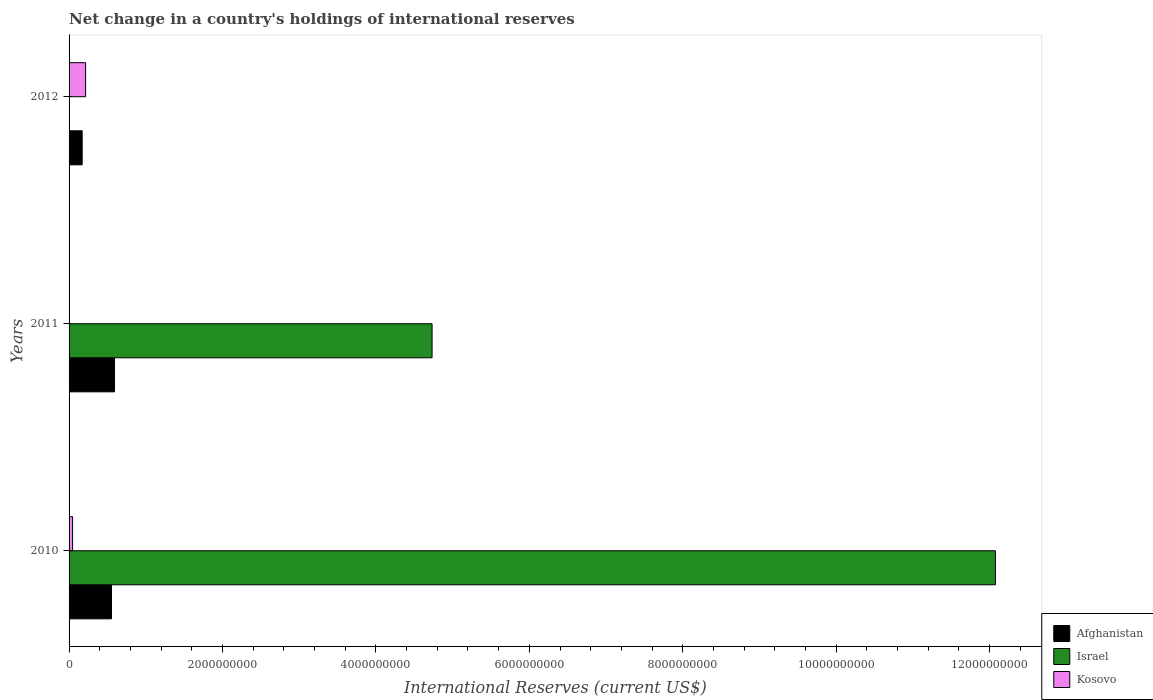Are the number of bars per tick equal to the number of legend labels?
Offer a terse response. No. Are the number of bars on each tick of the Y-axis equal?
Keep it short and to the point. No. What is the label of the 2nd group of bars from the top?
Give a very brief answer. 2011. In how many cases, is the number of bars for a given year not equal to the number of legend labels?
Provide a short and direct response. 2. Across all years, what is the maximum international reserves in Kosovo?
Provide a succinct answer. 2.16e+08. Across all years, what is the minimum international reserves in Israel?
Make the answer very short. 0. In which year was the international reserves in Israel maximum?
Give a very brief answer. 2010. What is the total international reserves in Kosovo in the graph?
Provide a short and direct response. 2.61e+08. What is the difference between the international reserves in Afghanistan in 2011 and that in 2012?
Give a very brief answer. 4.22e+08. What is the difference between the international reserves in Afghanistan in 2010 and the international reserves in Israel in 2012?
Offer a terse response. 5.53e+08. What is the average international reserves in Israel per year?
Your answer should be very brief. 5.60e+09. In the year 2012, what is the difference between the international reserves in Kosovo and international reserves in Afghanistan?
Provide a short and direct response. 4.49e+07. In how many years, is the international reserves in Kosovo greater than 800000000 US$?
Provide a succinct answer. 0. What is the ratio of the international reserves in Afghanistan in 2010 to that in 2011?
Offer a terse response. 0.93. Is the international reserves in Afghanistan in 2011 less than that in 2012?
Your answer should be very brief. No. What is the difference between the highest and the second highest international reserves in Afghanistan?
Give a very brief answer. 3.93e+07. What is the difference between the highest and the lowest international reserves in Afghanistan?
Your response must be concise. 4.22e+08. Is it the case that in every year, the sum of the international reserves in Kosovo and international reserves in Israel is greater than the international reserves in Afghanistan?
Keep it short and to the point. Yes. Are all the bars in the graph horizontal?
Make the answer very short. Yes. What is the difference between two consecutive major ticks on the X-axis?
Offer a very short reply. 2.00e+09. Does the graph contain any zero values?
Offer a terse response. Yes. Does the graph contain grids?
Your answer should be compact. No. How many legend labels are there?
Ensure brevity in your answer.  3. How are the legend labels stacked?
Offer a very short reply. Vertical. What is the title of the graph?
Make the answer very short. Net change in a country's holdings of international reserves. Does "Sao Tome and Principe" appear as one of the legend labels in the graph?
Provide a succinct answer. No. What is the label or title of the X-axis?
Make the answer very short. International Reserves (current US$). What is the label or title of the Y-axis?
Your answer should be compact. Years. What is the International Reserves (current US$) in Afghanistan in 2010?
Your response must be concise. 5.53e+08. What is the International Reserves (current US$) in Israel in 2010?
Your answer should be very brief. 1.21e+1. What is the International Reserves (current US$) in Kosovo in 2010?
Ensure brevity in your answer.  4.57e+07. What is the International Reserves (current US$) in Afghanistan in 2011?
Ensure brevity in your answer.  5.92e+08. What is the International Reserves (current US$) in Israel in 2011?
Provide a succinct answer. 4.73e+09. What is the International Reserves (current US$) of Kosovo in 2011?
Make the answer very short. 0. What is the International Reserves (current US$) in Afghanistan in 2012?
Your answer should be very brief. 1.71e+08. What is the International Reserves (current US$) of Kosovo in 2012?
Your answer should be compact. 2.16e+08. Across all years, what is the maximum International Reserves (current US$) in Afghanistan?
Make the answer very short. 5.92e+08. Across all years, what is the maximum International Reserves (current US$) of Israel?
Offer a very short reply. 1.21e+1. Across all years, what is the maximum International Reserves (current US$) in Kosovo?
Provide a succinct answer. 2.16e+08. Across all years, what is the minimum International Reserves (current US$) in Afghanistan?
Keep it short and to the point. 1.71e+08. Across all years, what is the minimum International Reserves (current US$) of Israel?
Offer a terse response. 0. Across all years, what is the minimum International Reserves (current US$) of Kosovo?
Ensure brevity in your answer.  0. What is the total International Reserves (current US$) of Afghanistan in the graph?
Your answer should be very brief. 1.32e+09. What is the total International Reserves (current US$) in Israel in the graph?
Give a very brief answer. 1.68e+1. What is the total International Reserves (current US$) in Kosovo in the graph?
Your answer should be very brief. 2.61e+08. What is the difference between the International Reserves (current US$) of Afghanistan in 2010 and that in 2011?
Offer a very short reply. -3.93e+07. What is the difference between the International Reserves (current US$) in Israel in 2010 and that in 2011?
Keep it short and to the point. 7.34e+09. What is the difference between the International Reserves (current US$) of Afghanistan in 2010 and that in 2012?
Make the answer very short. 3.82e+08. What is the difference between the International Reserves (current US$) in Kosovo in 2010 and that in 2012?
Give a very brief answer. -1.70e+08. What is the difference between the International Reserves (current US$) of Afghanistan in 2011 and that in 2012?
Give a very brief answer. 4.22e+08. What is the difference between the International Reserves (current US$) of Afghanistan in 2010 and the International Reserves (current US$) of Israel in 2011?
Give a very brief answer. -4.18e+09. What is the difference between the International Reserves (current US$) in Afghanistan in 2010 and the International Reserves (current US$) in Kosovo in 2012?
Provide a succinct answer. 3.37e+08. What is the difference between the International Reserves (current US$) in Israel in 2010 and the International Reserves (current US$) in Kosovo in 2012?
Make the answer very short. 1.19e+1. What is the difference between the International Reserves (current US$) of Afghanistan in 2011 and the International Reserves (current US$) of Kosovo in 2012?
Provide a short and direct response. 3.77e+08. What is the difference between the International Reserves (current US$) of Israel in 2011 and the International Reserves (current US$) of Kosovo in 2012?
Provide a succinct answer. 4.52e+09. What is the average International Reserves (current US$) in Afghanistan per year?
Provide a succinct answer. 4.39e+08. What is the average International Reserves (current US$) in Israel per year?
Provide a succinct answer. 5.60e+09. What is the average International Reserves (current US$) in Kosovo per year?
Provide a succinct answer. 8.71e+07. In the year 2010, what is the difference between the International Reserves (current US$) in Afghanistan and International Reserves (current US$) in Israel?
Provide a short and direct response. -1.15e+1. In the year 2010, what is the difference between the International Reserves (current US$) of Afghanistan and International Reserves (current US$) of Kosovo?
Give a very brief answer. 5.07e+08. In the year 2010, what is the difference between the International Reserves (current US$) in Israel and International Reserves (current US$) in Kosovo?
Provide a short and direct response. 1.20e+1. In the year 2011, what is the difference between the International Reserves (current US$) of Afghanistan and International Reserves (current US$) of Israel?
Provide a succinct answer. -4.14e+09. In the year 2012, what is the difference between the International Reserves (current US$) of Afghanistan and International Reserves (current US$) of Kosovo?
Offer a terse response. -4.49e+07. What is the ratio of the International Reserves (current US$) of Afghanistan in 2010 to that in 2011?
Provide a short and direct response. 0.93. What is the ratio of the International Reserves (current US$) in Israel in 2010 to that in 2011?
Provide a short and direct response. 2.55. What is the ratio of the International Reserves (current US$) in Afghanistan in 2010 to that in 2012?
Provide a short and direct response. 3.24. What is the ratio of the International Reserves (current US$) of Kosovo in 2010 to that in 2012?
Offer a terse response. 0.21. What is the ratio of the International Reserves (current US$) in Afghanistan in 2011 to that in 2012?
Make the answer very short. 3.47. What is the difference between the highest and the second highest International Reserves (current US$) of Afghanistan?
Give a very brief answer. 3.93e+07. What is the difference between the highest and the lowest International Reserves (current US$) in Afghanistan?
Offer a terse response. 4.22e+08. What is the difference between the highest and the lowest International Reserves (current US$) in Israel?
Keep it short and to the point. 1.21e+1. What is the difference between the highest and the lowest International Reserves (current US$) in Kosovo?
Keep it short and to the point. 2.16e+08. 